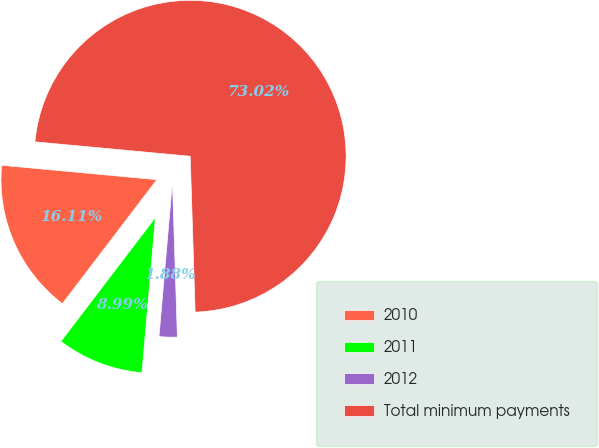Convert chart. <chart><loc_0><loc_0><loc_500><loc_500><pie_chart><fcel>2010<fcel>2011<fcel>2012<fcel>Total minimum payments<nl><fcel>16.11%<fcel>8.99%<fcel>1.88%<fcel>73.03%<nl></chart> 